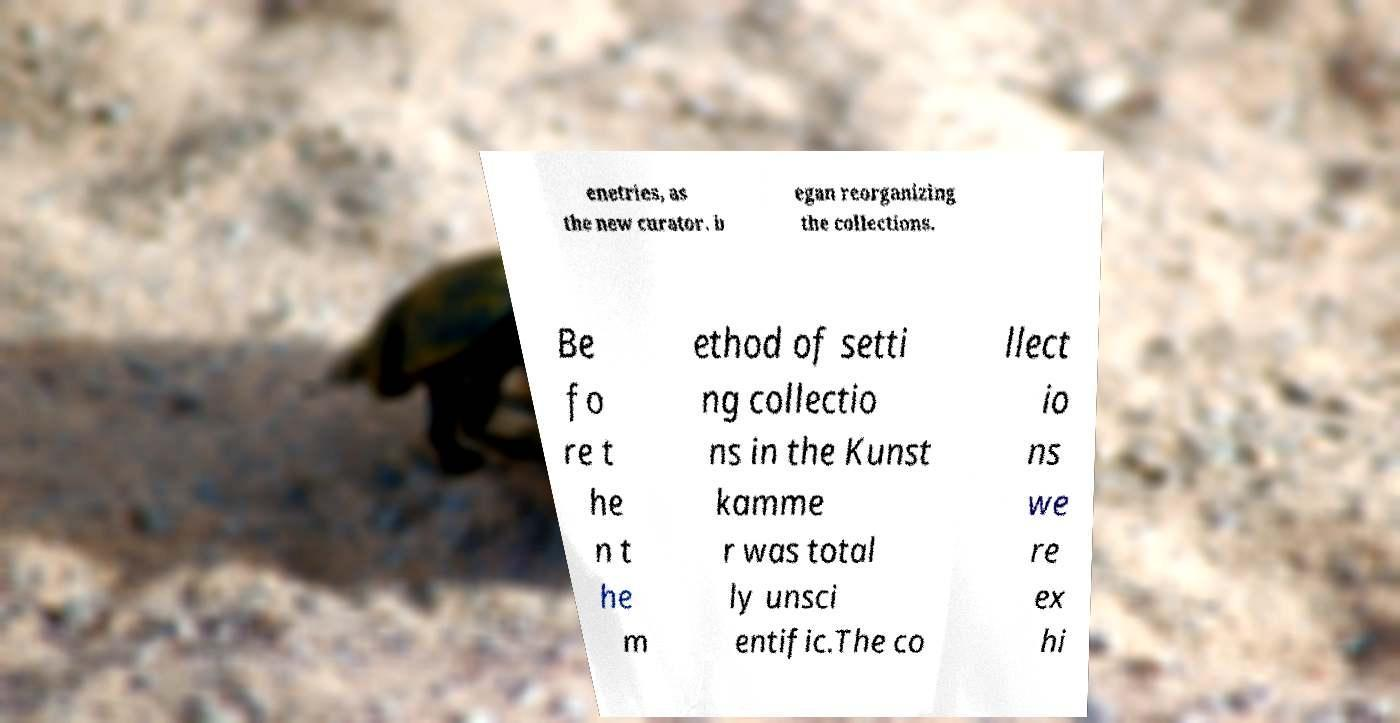Could you extract and type out the text from this image? enetries, as the new curator. b egan reorganizing the collections. Be fo re t he n t he m ethod of setti ng collectio ns in the Kunst kamme r was total ly unsci entific.The co llect io ns we re ex hi 